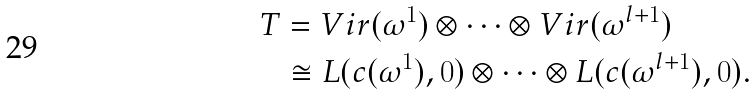<formula> <loc_0><loc_0><loc_500><loc_500>T & = V i r ( \omega ^ { 1 } ) \otimes \cdots \otimes V i r ( \omega ^ { l + 1 } ) \\ \ & \cong L ( c ( \omega ^ { 1 } ) , 0 ) \otimes \cdots \otimes L ( c ( \omega ^ { l + 1 } ) , 0 ) .</formula> 